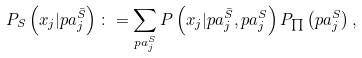Convert formula to latex. <formula><loc_0><loc_0><loc_500><loc_500>P _ { S } \left ( x _ { j } | p a ^ { \bar { S } } _ { j } \right ) \colon = \sum _ { p a _ { j } ^ { S } } P \left ( x _ { j } | p a ^ { \bar { S } } _ { j } , p a _ { j } ^ { S } \right ) P _ { \prod } \left ( p a _ { j } ^ { S } \right ) ,</formula> 